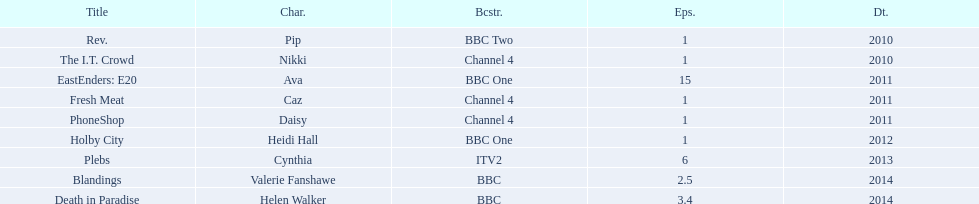Were there more than four episodes that featured cynthia? Yes. 